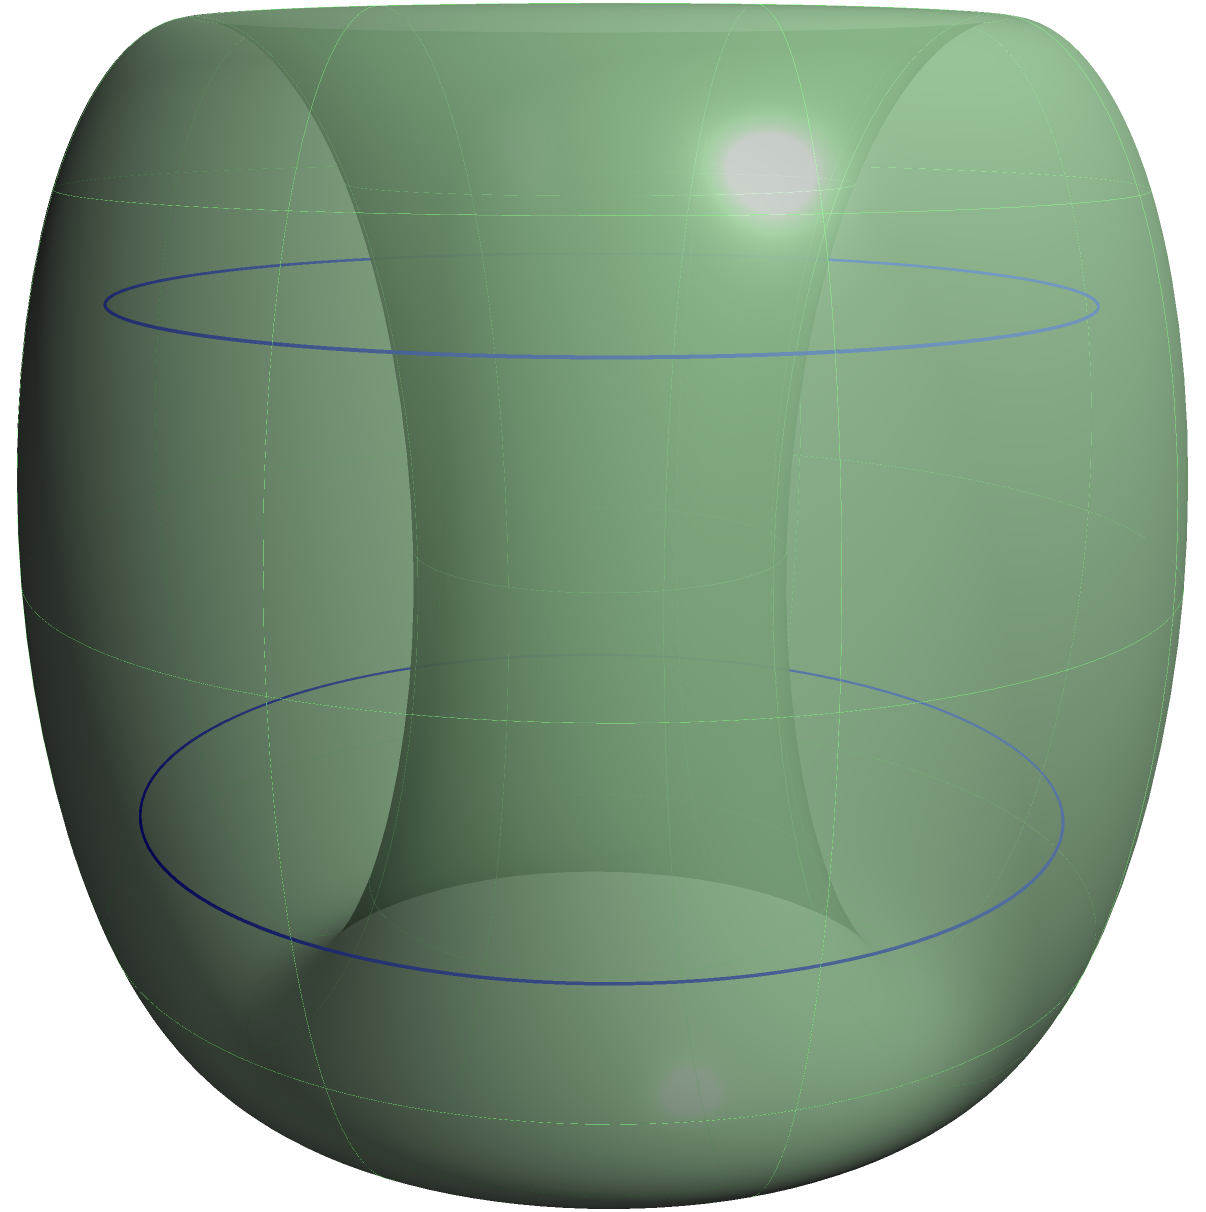A wind turbine manufacturer has designed a novel blade system that forms a surface similar to a torus when rotating. If the surface created by the rotating blades has two holes (as shown in the figure), what is the genus of this surface? To determine the genus of the surface, we need to follow these steps:

1) First, recall that the genus of a surface is the maximum number of simple closed curves that can be drawn on the surface without separating it into two or more pieces.

2) The surface shown in the figure is topologically equivalent to a double torus, also known as a 2-torus.

3) For a single torus (like a donut shape), we can draw one closed curve around the hole without separating the surface. The genus of a single torus is 1.

4) In this case, we have two "holes" in our surface. We can draw two independent closed curves:
   - One around the first hole
   - One around the second hole

5) These two curves do not separate the surface into disconnected pieces.

6) If we were to draw a third independent closed curve, it would necessarily separate the surface.

7) Therefore, the maximum number of simple closed curves that can be drawn without separating the surface is 2.

Thus, the genus of this surface is 2.
Answer: 2 